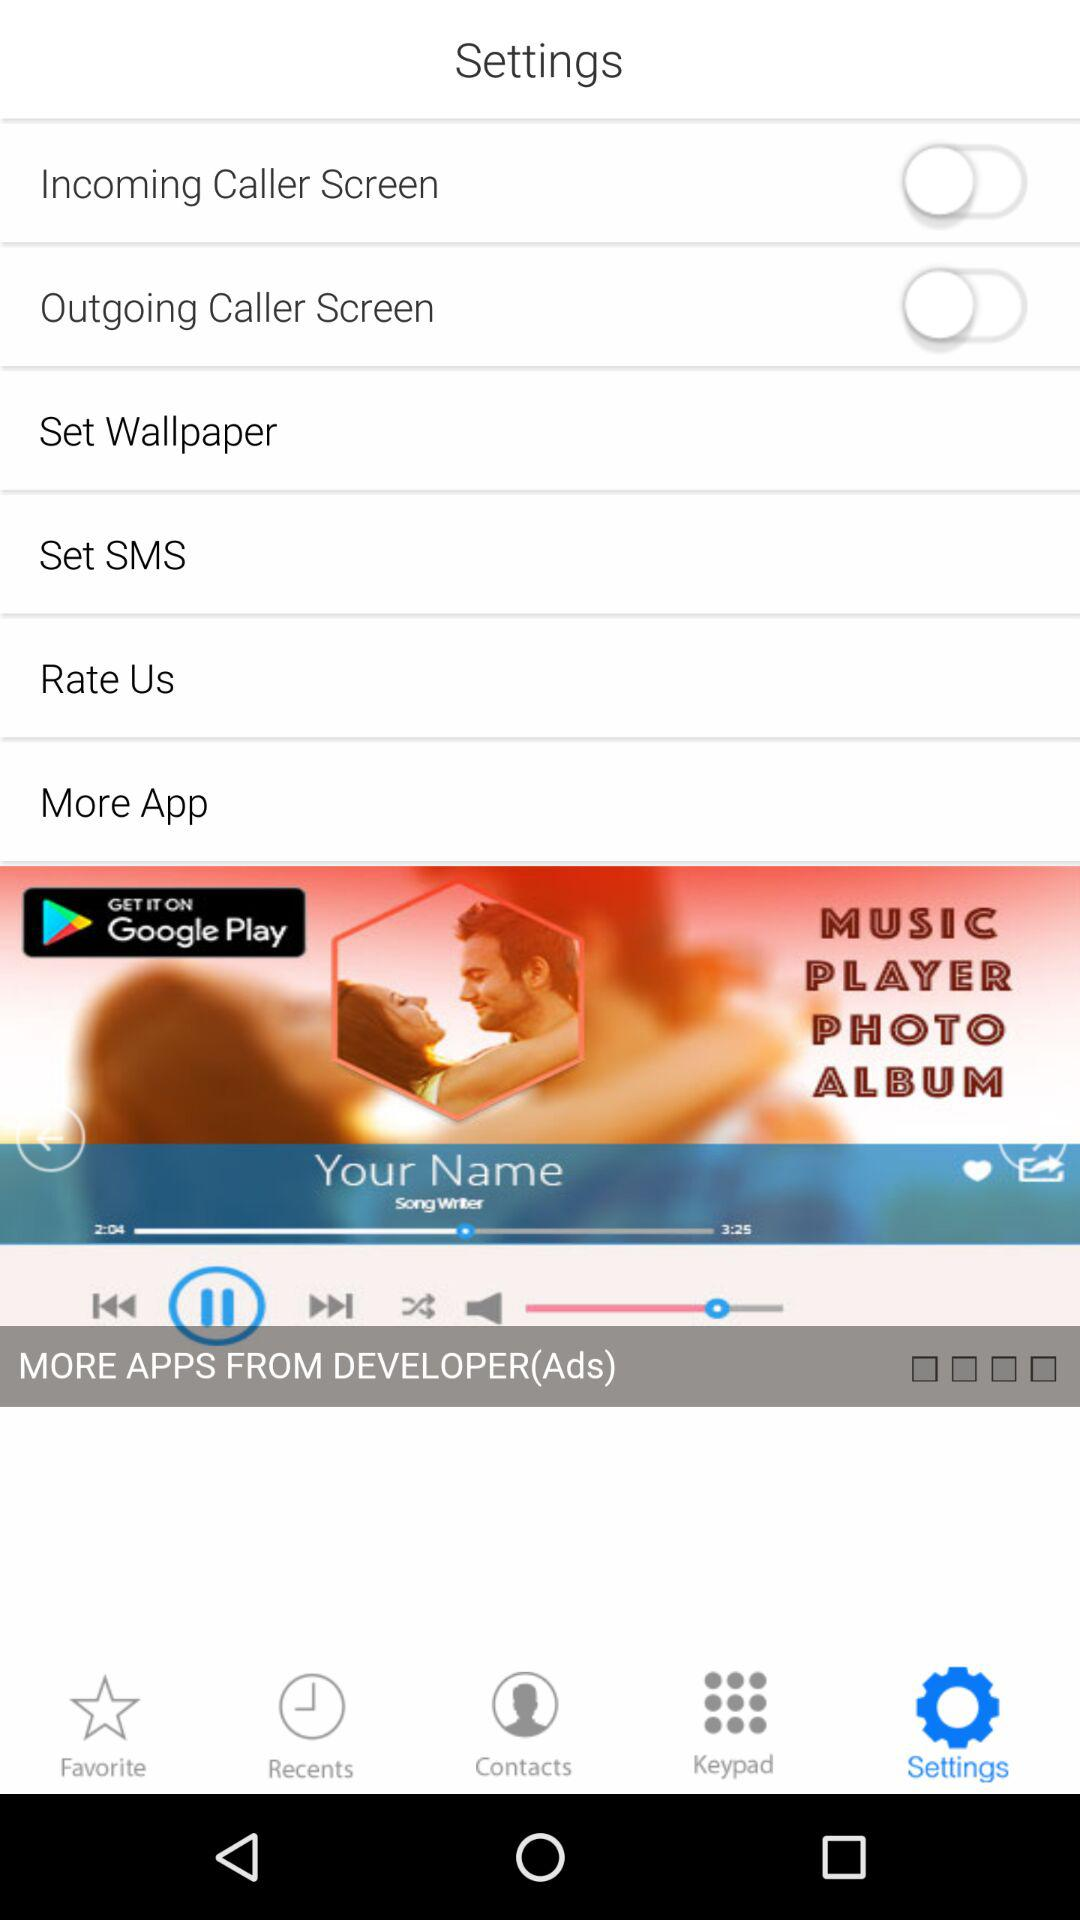Which tab is selected? The selected tab is "Settings". 